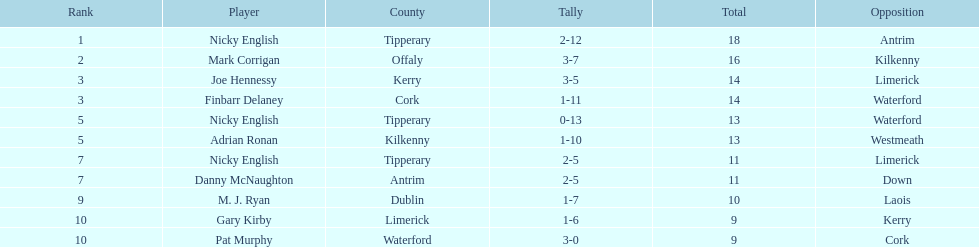What is the least total on the list? 9. 